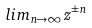Convert formula to latex. <formula><loc_0><loc_0><loc_500><loc_500>l i m _ { n \rightarrow \infty } z ^ { \pm n }</formula> 